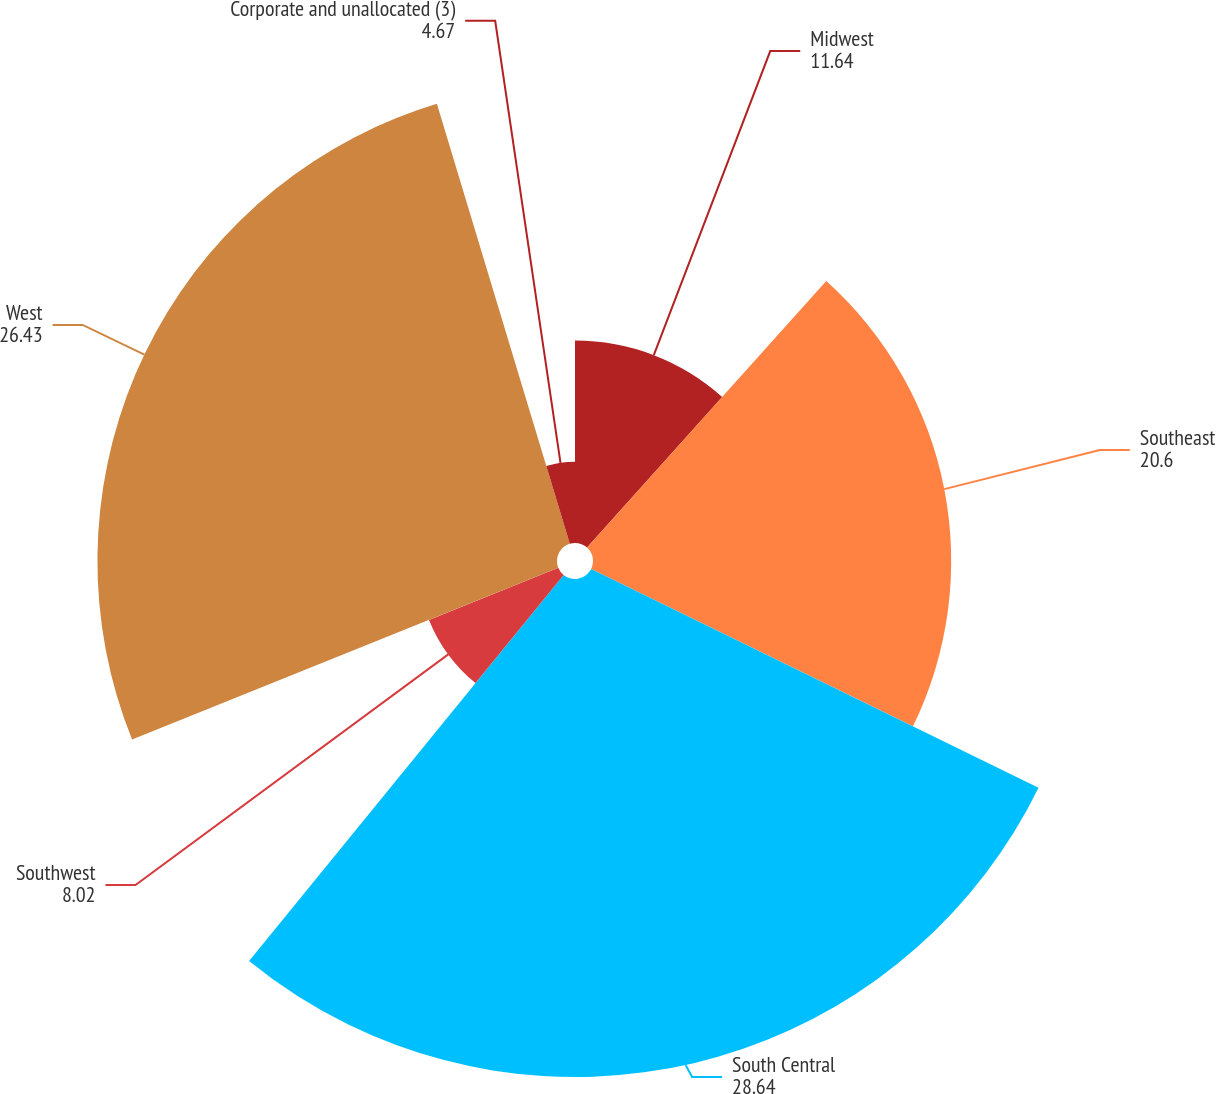Convert chart. <chart><loc_0><loc_0><loc_500><loc_500><pie_chart><fcel>Midwest<fcel>Southeast<fcel>South Central<fcel>Southwest<fcel>West<fcel>Corporate and unallocated (3)<nl><fcel>11.64%<fcel>20.6%<fcel>28.64%<fcel>8.02%<fcel>26.43%<fcel>4.67%<nl></chart> 